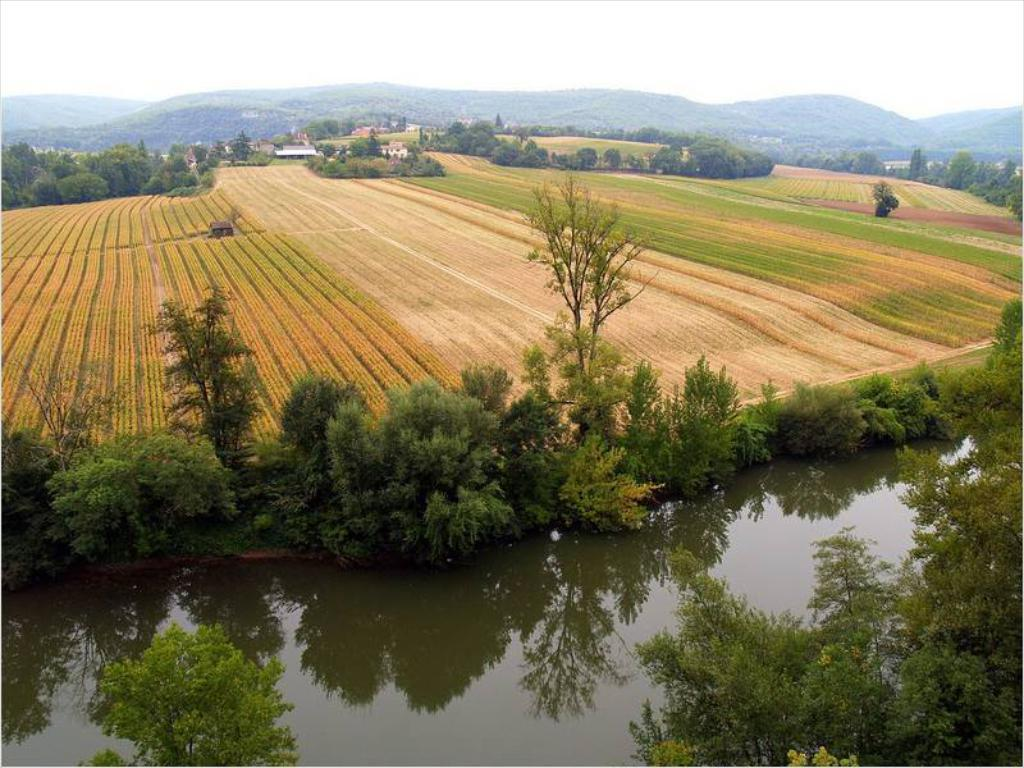What type of landscape is depicted in the image? There is a field in the image. What types of vegetation can be seen in the image? There are plants, trees, and grass visible in the image. Is there any water visible in the image? Yes, there is water visible in the image. What type of tail can be seen on the letter in the image? There is no letter or tail present in the image. How is the thread used in the image? There is no thread present in the image. 